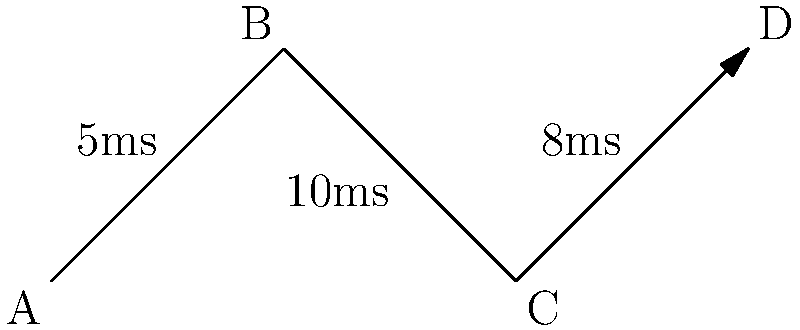Given the network topology diagram above, calculate the end-to-end latency for a data packet traveling from node A to node D. Assume that processing time at each node is negligible. Express your answer in milliseconds. To calculate the end-to-end latency, we need to sum up the latencies of each link in the path from node A to node D:

1. Latency from A to B: 5 ms
2. Latency from B to C: 10 ms
3. Latency from C to D: 8 ms

Total end-to-end latency:
$$ \text{Latency}_{\text{total}} = 5 \text{ ms} + 10 \text{ ms} + 8 \text{ ms} = 23 \text{ ms} $$

Since we're assuming negligible processing time at each node, we don't need to add any additional time for node processing.
Answer: 23 ms 